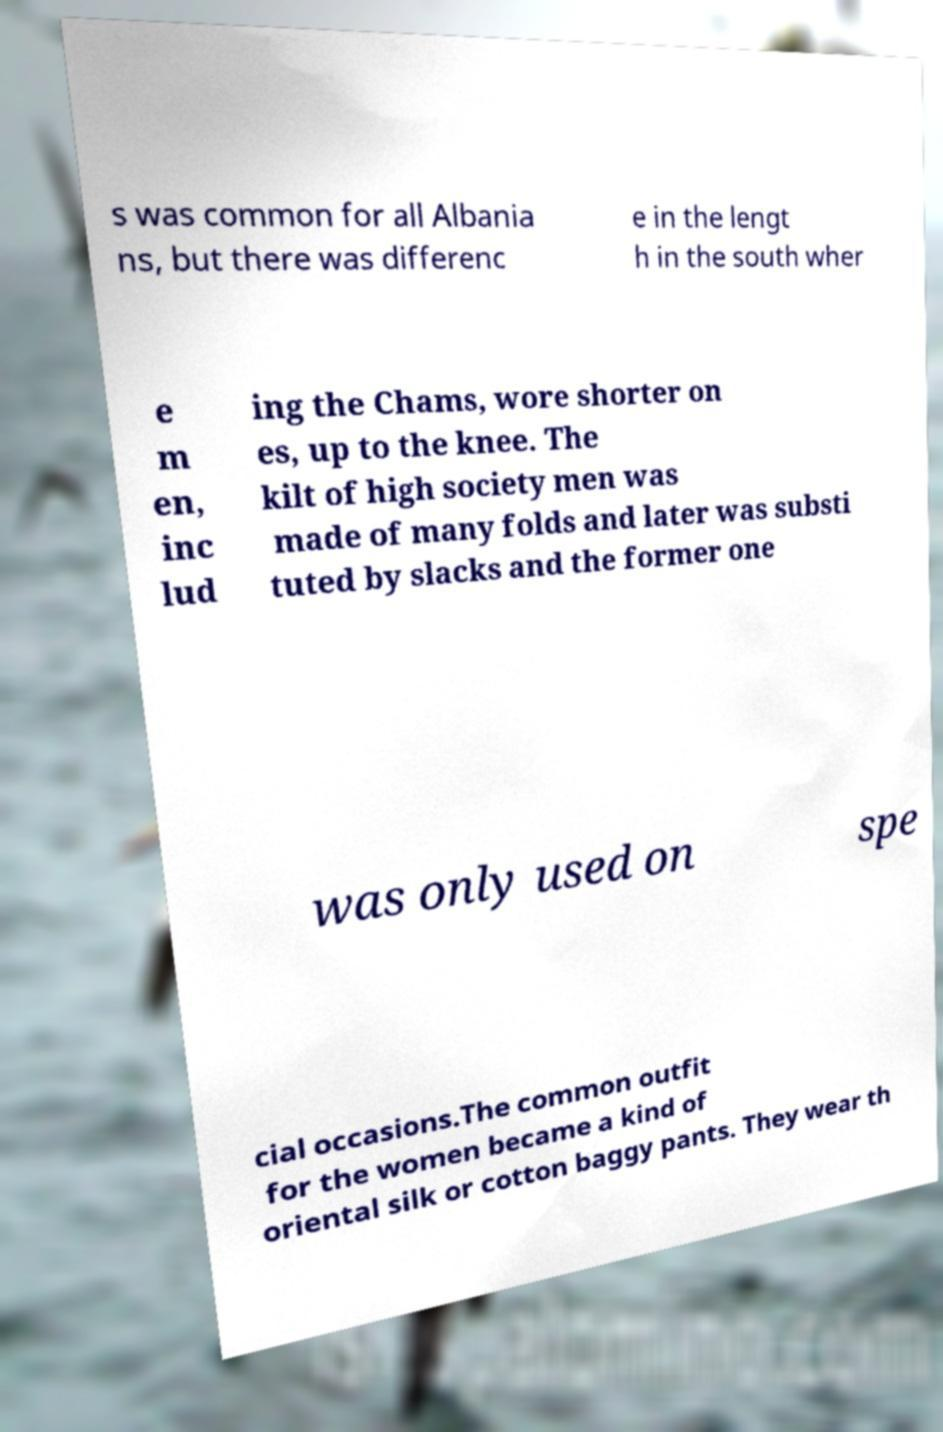There's text embedded in this image that I need extracted. Can you transcribe it verbatim? s was common for all Albania ns, but there was differenc e in the lengt h in the south wher e m en, inc lud ing the Chams, wore shorter on es, up to the knee. The kilt of high society men was made of many folds and later was substi tuted by slacks and the former one was only used on spe cial occasions.The common outfit for the women became a kind of oriental silk or cotton baggy pants. They wear th 